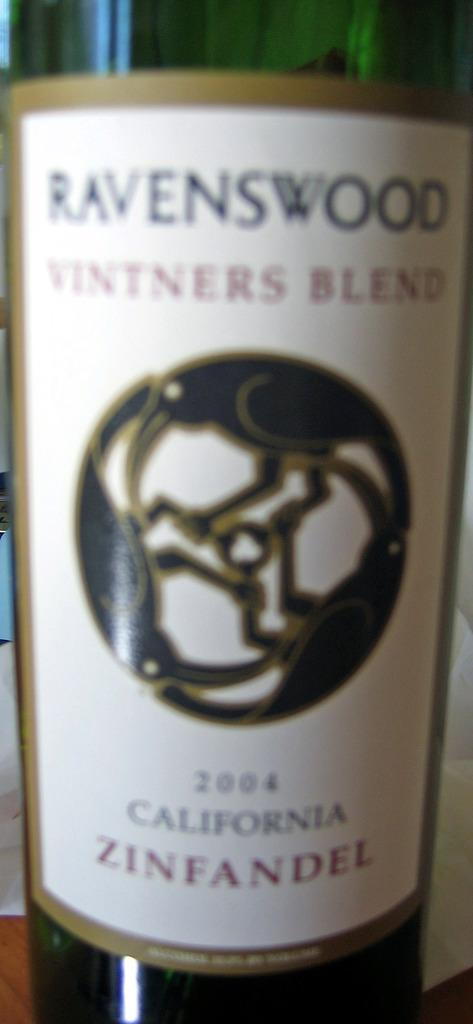<image>
Offer a succinct explanation of the picture presented. the word California that is on a bottle 